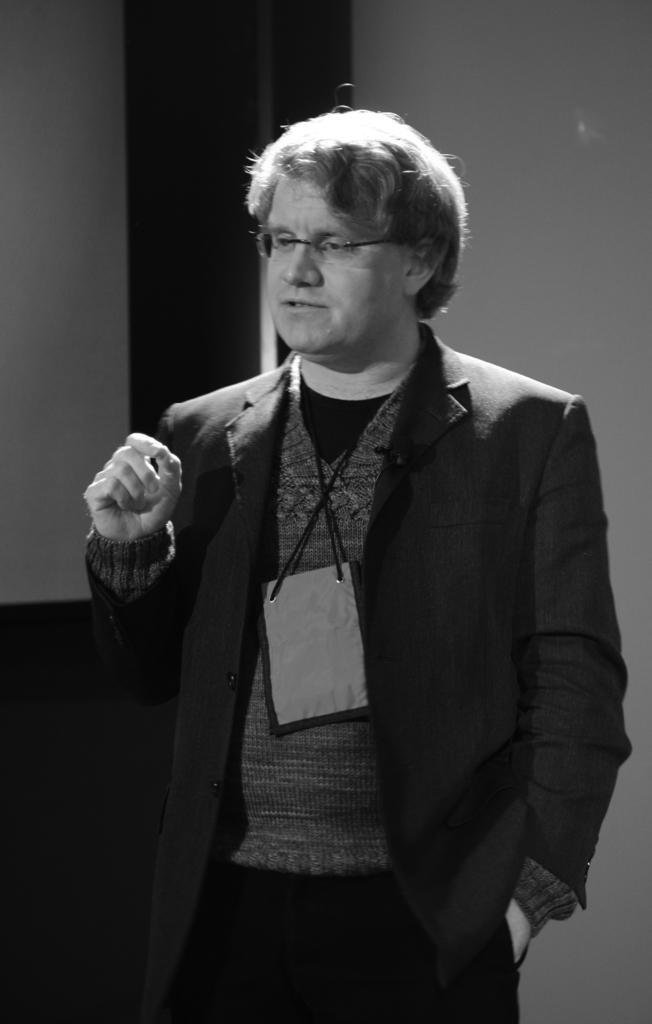Could you give a brief overview of what you see in this image? It is a black and white picture. In the center of the image we can see a person is standing and he is in a different costume. In the background there is a wall. 